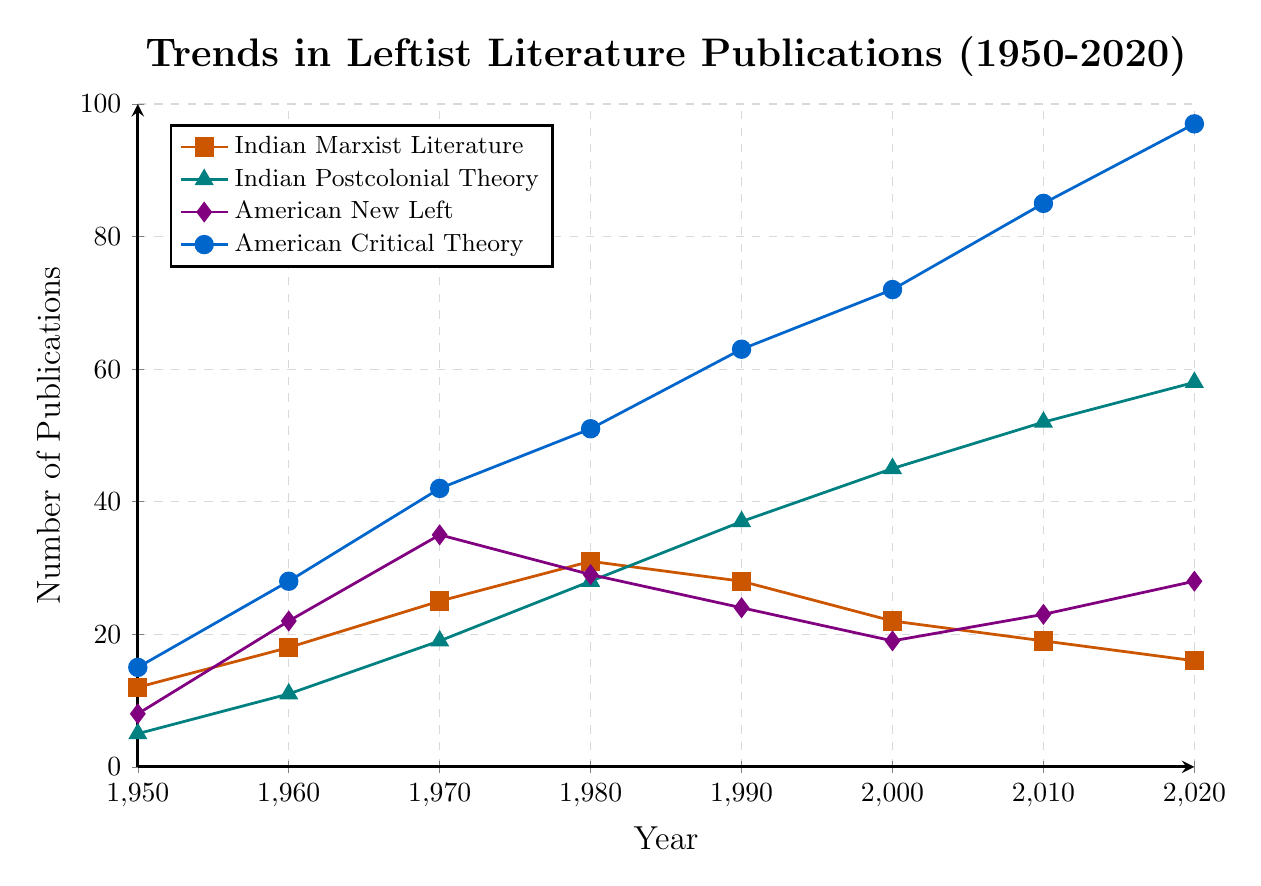What trend can be observed for Indian Marxist Literature publications between 1950 and 2020? The data for Indian Marxist Literature shows a general decrease in publications over time. The number peaks in 1980 and then consistently decreases.
Answer: Decreasing trend Which category had the highest number of publications in 2020? By examining the height of the final markers in the figure for each category, American Critical Theory had the highest publications in 2020 with 97 publications.
Answer: American Critical Theory How do the trends of Indian Postcolonial Theory and American New Left publications compare from 1950 to 2020? Indian Postcolonial Theory shows a steady increase over the years, whereas American New Left peaks in 1970, declines, and then shows a slight recovery in 2020.
Answer: Indian Postcolonial Theory consistently increased, American New Left fluctuated Between 1950 and 1990, which category experienced the largest growth in publications? By comparing the initial and final number of publications for each category over the time period, Indian Postcolonial Theory increased from 5 in 1950 to 37 in 1990, a growth of 32 publications.
Answer: Indian Postcolonial Theory In which decade did American Critical Theory publications surpass 50 publications? Reviewing the data points for American Critical Theory, publications surpassed 50 in the 1980s.
Answer: 1980s What is the average number of publications for Indian Postcolonial Theory from 1950 to 2020? Sum of publications from 1950 to 2020: (5+11+19+28+37+45+52+58)=255. Dividing by 8 decades, the average is 255/8.
Answer: 31.875 What are the differences in the number of publications between Indian Marxist Literature and American New Left in 1970? Comparing the data for both categories in 1970, Indian Marxist Literature had 25 publications, and American New Left had 35. Therefore, the difference is 35 - 25.
Answer: 10 How many times did Indian Marxist Literature publications peak during the period from 1950 to 2020? By examining the height of the markers for Indian Marxist Literature, it peaked once in 1980 at 31 publications before declining.
Answer: Once Determine the total publications of American Critical Theory from 1990 to 2020. Summing the data points from 1990, 2000, 2010, and 2020 for American Critical Theory: 63 + 72 + 85 + 97 = 317.
Answer: 317 